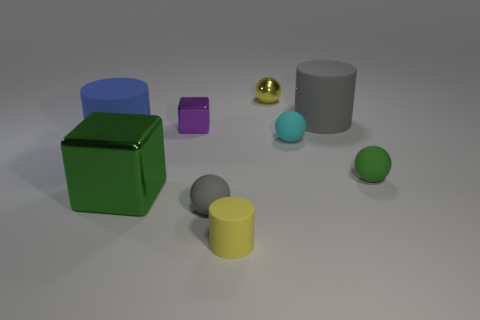Subtract 2 balls. How many balls are left? 2 Subtract all cylinders. How many objects are left? 6 Subtract 0 red spheres. How many objects are left? 9 Subtract all green things. Subtract all cyan spheres. How many objects are left? 6 Add 7 large blue matte things. How many large blue matte things are left? 8 Add 2 yellow objects. How many yellow objects exist? 4 